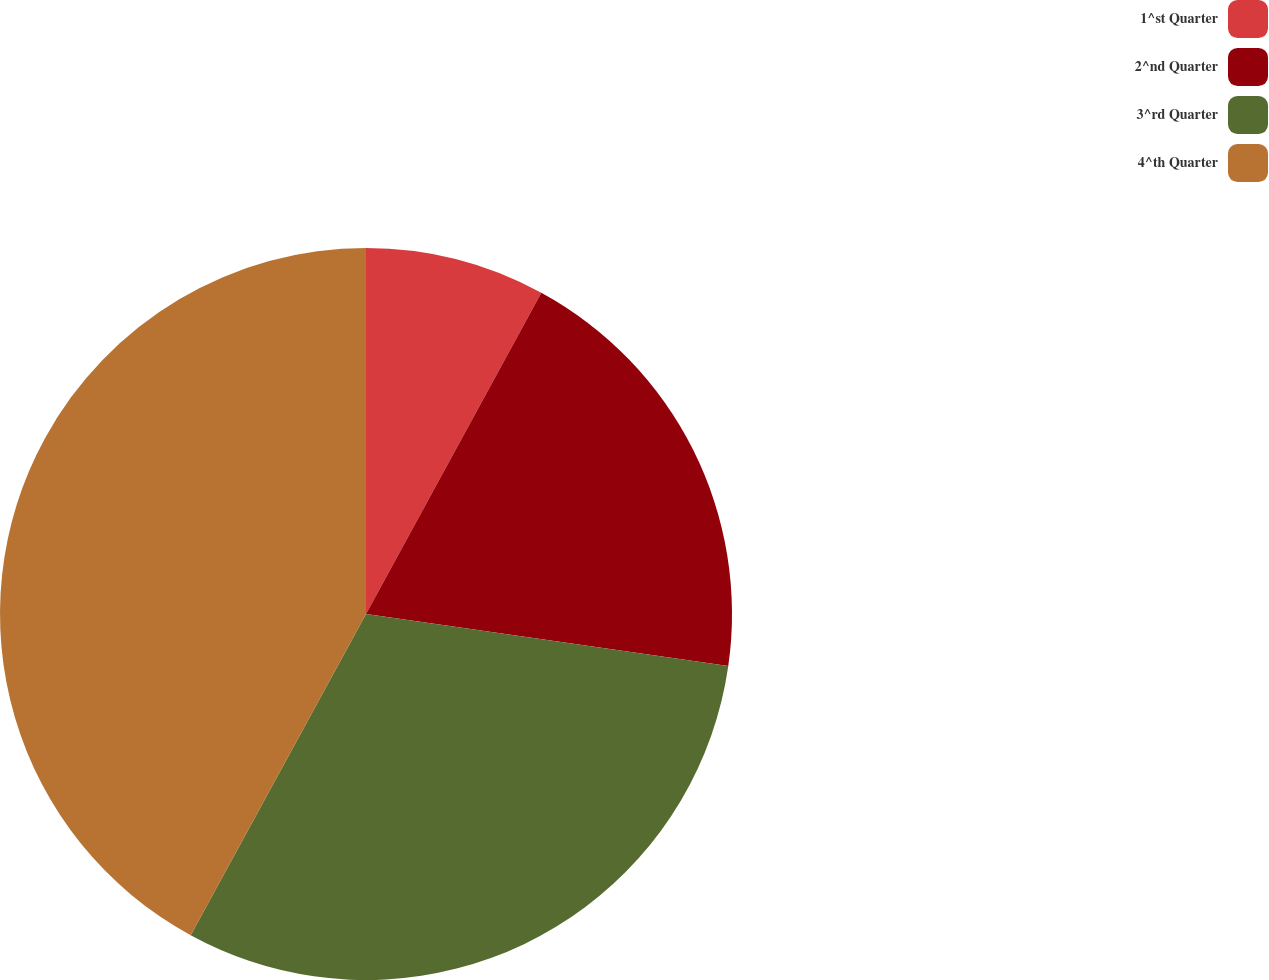<chart> <loc_0><loc_0><loc_500><loc_500><pie_chart><fcel>1^st Quarter<fcel>2^nd Quarter<fcel>3^rd Quarter<fcel>4^th Quarter<nl><fcel>7.95%<fcel>19.32%<fcel>30.68%<fcel>42.05%<nl></chart> 